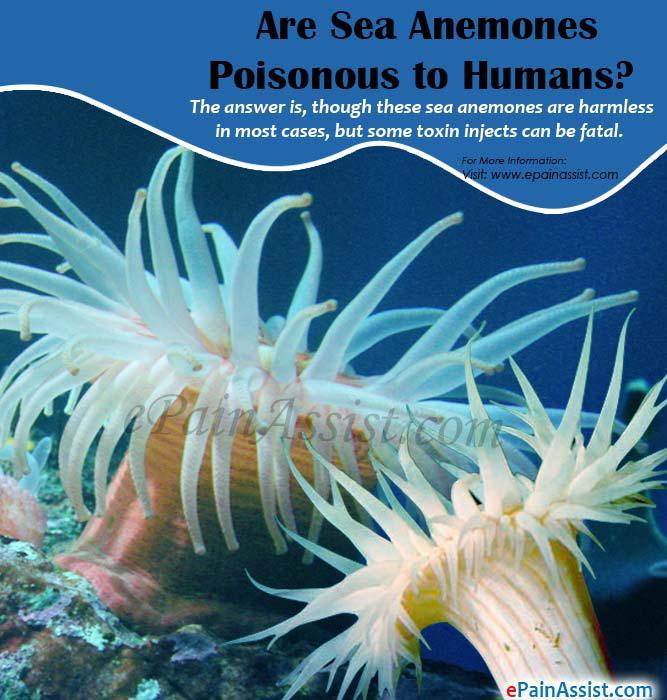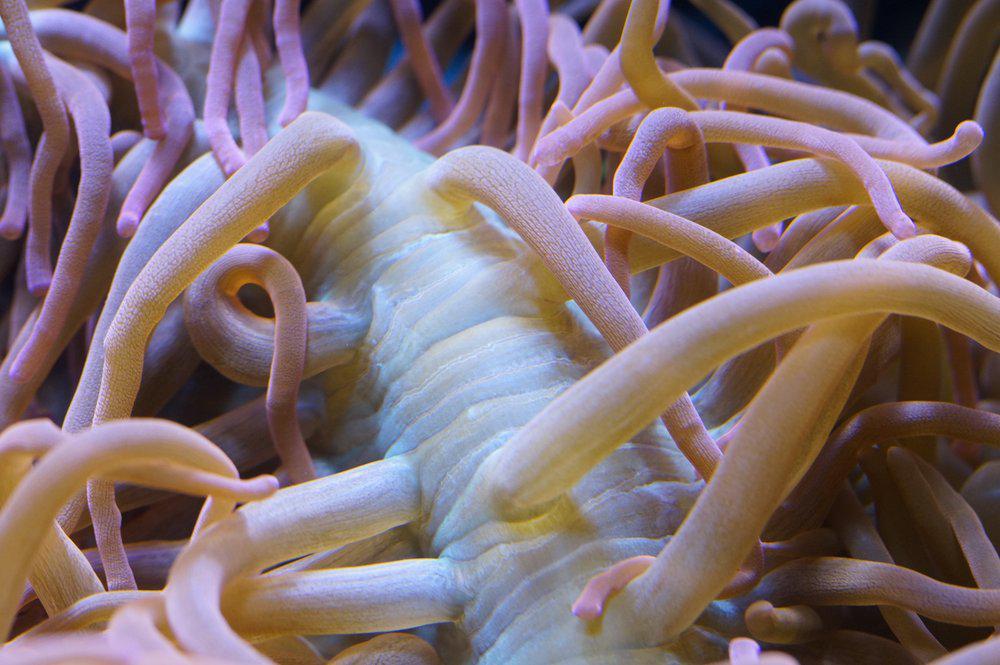The first image is the image on the left, the second image is the image on the right. Assess this claim about the two images: "One image shows the reddish-orange tinged front claws of a crustacean emerging from something with green tendrils.". Correct or not? Answer yes or no. No. The first image is the image on the left, the second image is the image on the right. For the images shown, is this caption "At least one clown fish is nestled among the sea anemones." true? Answer yes or no. No. 